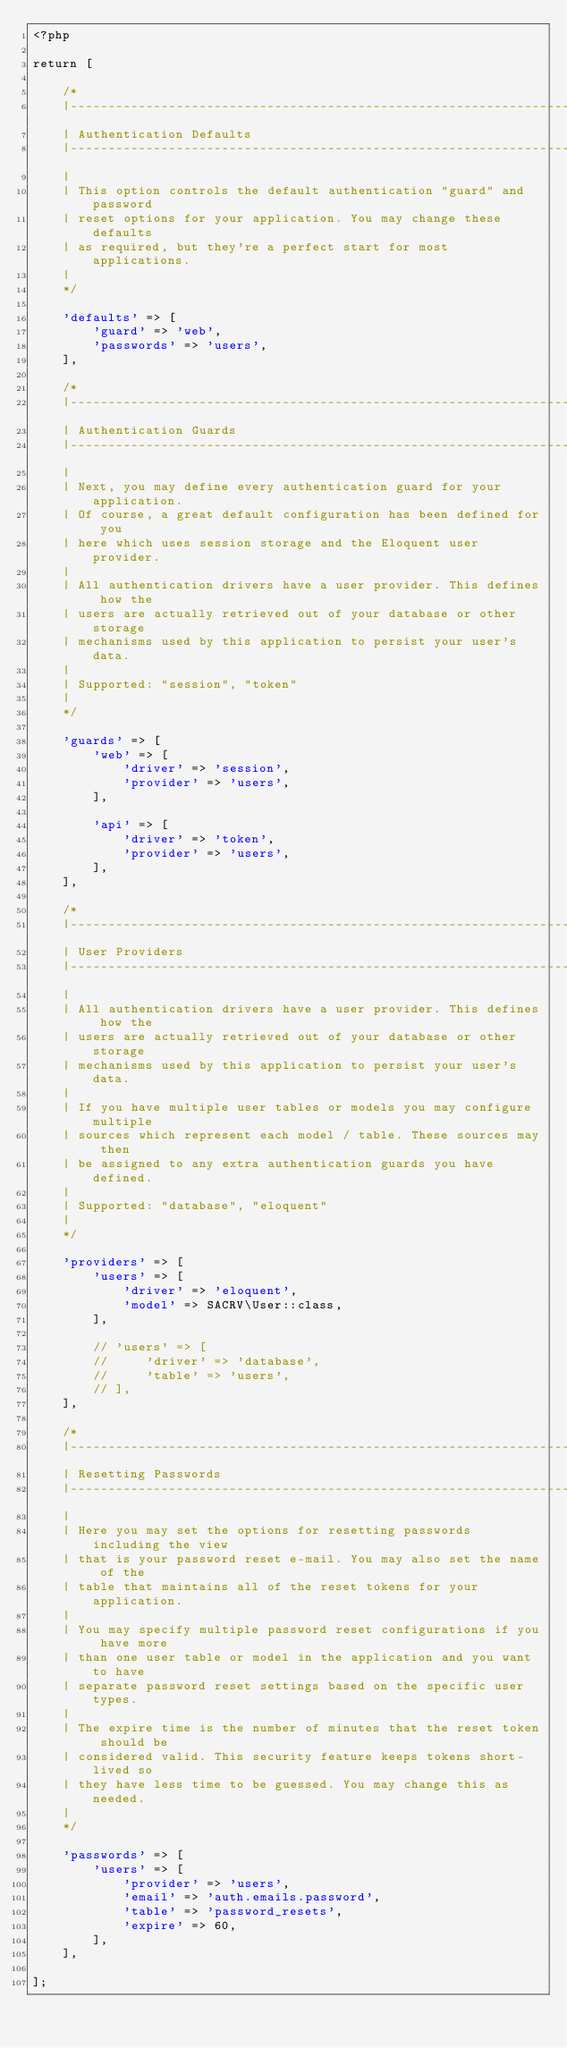Convert code to text. <code><loc_0><loc_0><loc_500><loc_500><_PHP_><?php

return [

    /*
    |--------------------------------------------------------------------------
    | Authentication Defaults
    |--------------------------------------------------------------------------
    |
    | This option controls the default authentication "guard" and password
    | reset options for your application. You may change these defaults
    | as required, but they're a perfect start for most applications.
    |
    */

    'defaults' => [
        'guard' => 'web',
        'passwords' => 'users',
    ],

    /*
    |--------------------------------------------------------------------------
    | Authentication Guards
    |--------------------------------------------------------------------------
    |
    | Next, you may define every authentication guard for your application.
    | Of course, a great default configuration has been defined for you
    | here which uses session storage and the Eloquent user provider.
    |
    | All authentication drivers have a user provider. This defines how the
    | users are actually retrieved out of your database or other storage
    | mechanisms used by this application to persist your user's data.
    |
    | Supported: "session", "token"
    |
    */

    'guards' => [
        'web' => [
            'driver' => 'session',
            'provider' => 'users',
        ],

        'api' => [
            'driver' => 'token',
            'provider' => 'users',
        ],
    ],

    /*
    |--------------------------------------------------------------------------
    | User Providers
    |--------------------------------------------------------------------------
    |
    | All authentication drivers have a user provider. This defines how the
    | users are actually retrieved out of your database or other storage
    | mechanisms used by this application to persist your user's data.
    |
    | If you have multiple user tables or models you may configure multiple
    | sources which represent each model / table. These sources may then
    | be assigned to any extra authentication guards you have defined.
    |
    | Supported: "database", "eloquent"
    |
    */

    'providers' => [
        'users' => [
            'driver' => 'eloquent',
            'model' => SACRV\User::class,
        ],

        // 'users' => [
        //     'driver' => 'database',
        //     'table' => 'users',
        // ],
    ],

    /*
    |--------------------------------------------------------------------------
    | Resetting Passwords
    |--------------------------------------------------------------------------
    |
    | Here you may set the options for resetting passwords including the view
    | that is your password reset e-mail. You may also set the name of the
    | table that maintains all of the reset tokens for your application.
    |
    | You may specify multiple password reset configurations if you have more
    | than one user table or model in the application and you want to have
    | separate password reset settings based on the specific user types.
    |
    | The expire time is the number of minutes that the reset token should be
    | considered valid. This security feature keeps tokens short-lived so
    | they have less time to be guessed. You may change this as needed.
    |
    */

    'passwords' => [
        'users' => [
            'provider' => 'users',
            'email' => 'auth.emails.password',
            'table' => 'password_resets',
            'expire' => 60,
        ],
    ],

];
</code> 